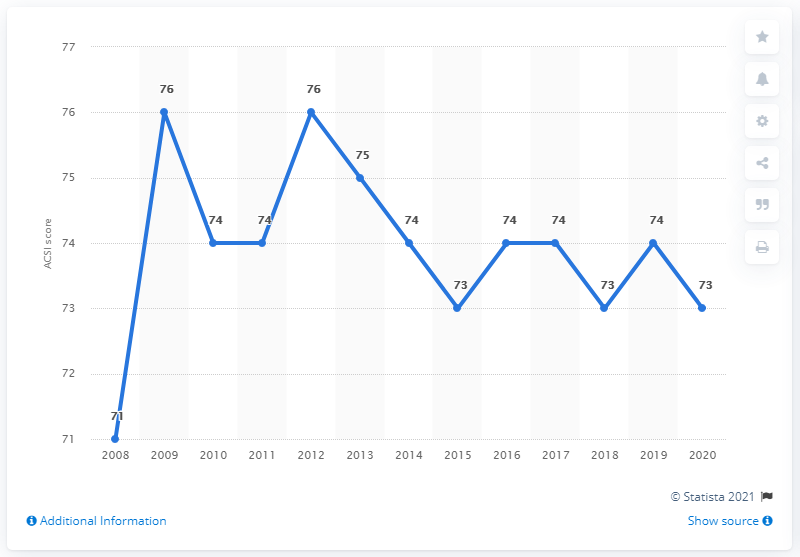Point out several critical features in this image. In 2009 and 2012, Choice Hotels received a highest score of 76. What is the value for 2015? It is 73. Choice Hotels' American Customer Satisfaction Index (ACSI) score in 2020 was 73, which indicates that the company's customers were generally satisfied with their experiences at Choice Hotels properties during that year. The result of taking the highest value and lowest value and dividing them by 2 would be 73.5. 